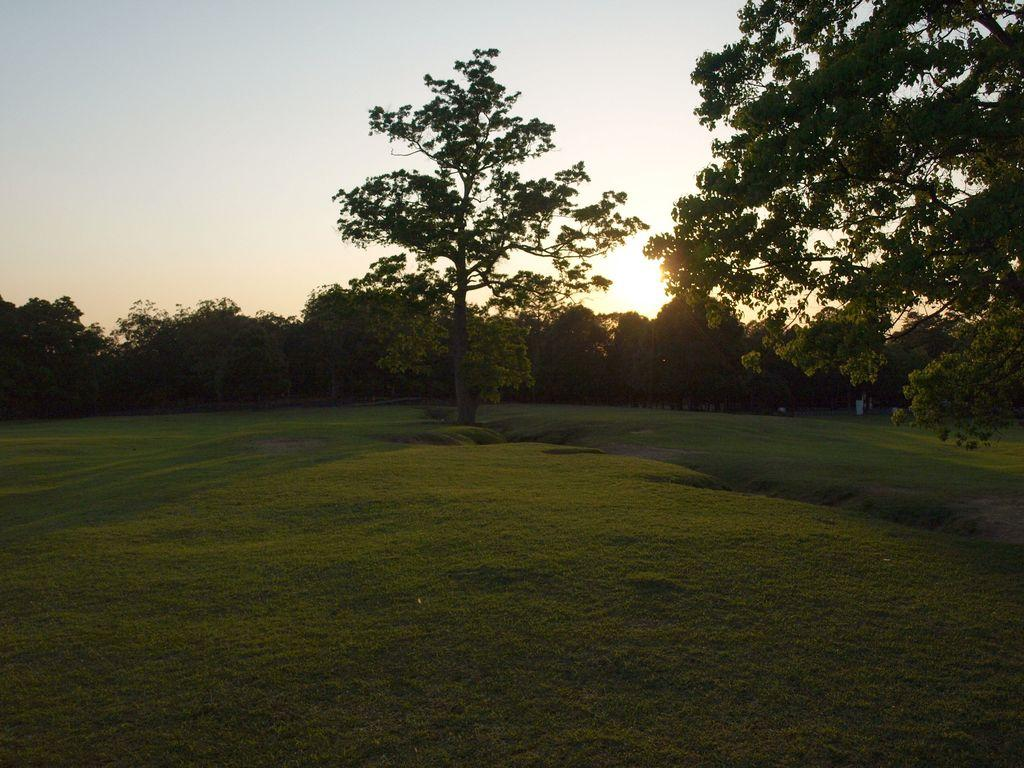What type of vegetation can be seen in the image? There is grass in the image. What else can be seen in the image besides grass? There are trees in the image. What is the condition of the sky in the image? The sky is clear in the image. What time of day is depicted in the image? There is a sunset in the image, indicating that it is late afternoon or early evening. What rule is being enforced by the tramp in the image? There is no tramp present in the image, and therefore no rule enforcement can be observed. How does the drain contribute to the image's composition? There is no drain present in the image. 